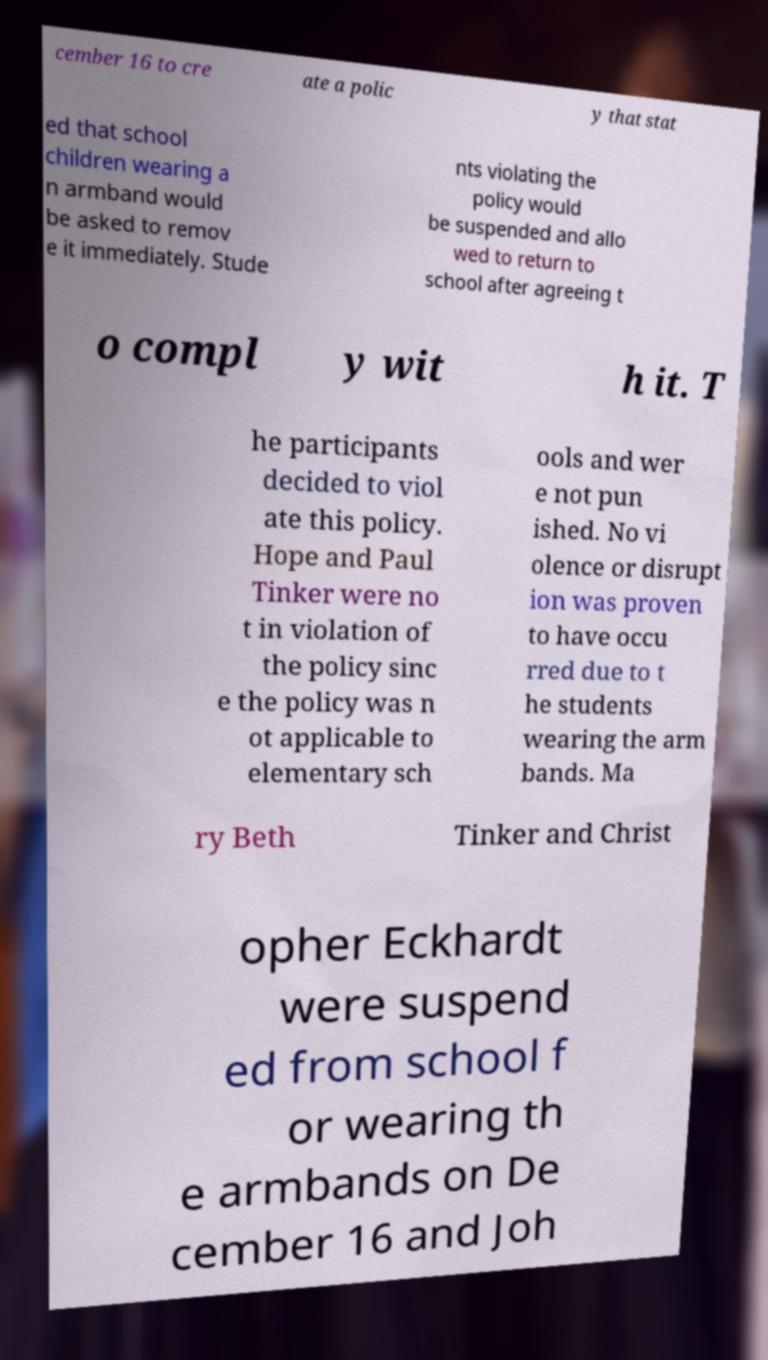Could you extract and type out the text from this image? cember 16 to cre ate a polic y that stat ed that school children wearing a n armband would be asked to remov e it immediately. Stude nts violating the policy would be suspended and allo wed to return to school after agreeing t o compl y wit h it. T he participants decided to viol ate this policy. Hope and Paul Tinker were no t in violation of the policy sinc e the policy was n ot applicable to elementary sch ools and wer e not pun ished. No vi olence or disrupt ion was proven to have occu rred due to t he students wearing the arm bands. Ma ry Beth Tinker and Christ opher Eckhardt were suspend ed from school f or wearing th e armbands on De cember 16 and Joh 